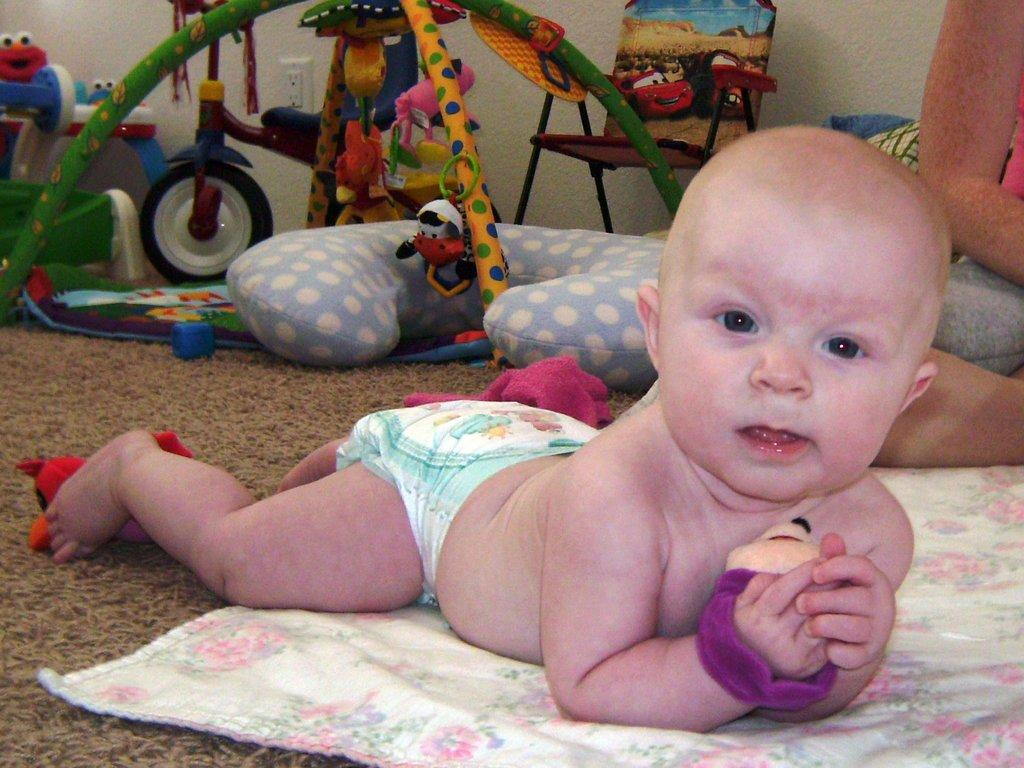What is the main subject of the image? The main subject of the image is a baby. What is the baby's position in the image? The baby is lying down on the floor. Who or what is the baby looking at? The baby is looking at someone. What type of organization is the baby affiliated with in the image? There is no indication in the image that the baby is affiliated with any organization. What tax implications might be associated with the baby in the image? There is no information in the image to suggest any tax implications related to the baby. 